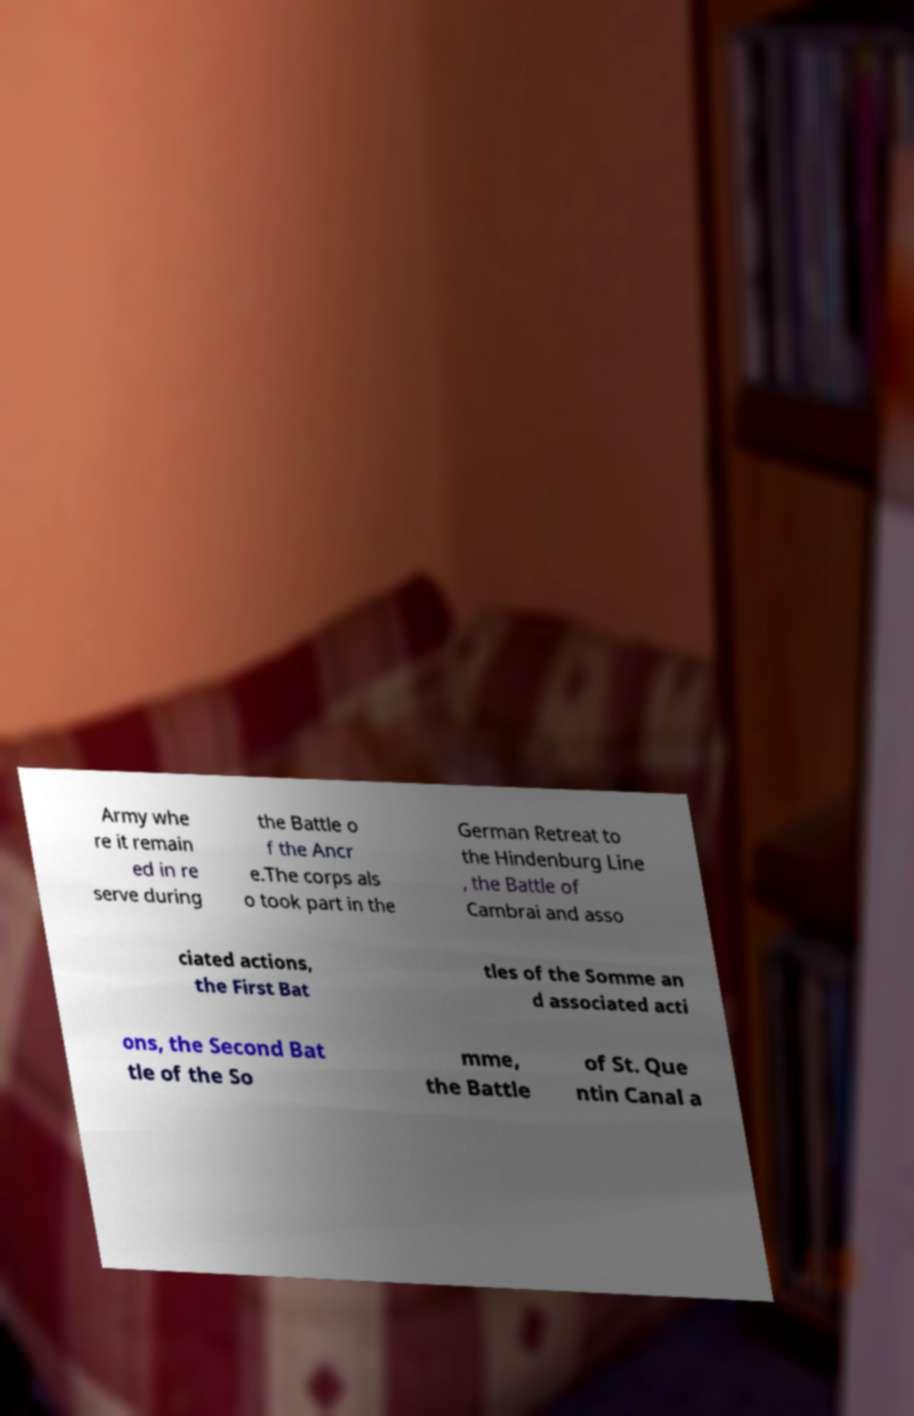Could you extract and type out the text from this image? Army whe re it remain ed in re serve during the Battle o f the Ancr e.The corps als o took part in the German Retreat to the Hindenburg Line , the Battle of Cambrai and asso ciated actions, the First Bat tles of the Somme an d associated acti ons, the Second Bat tle of the So mme, the Battle of St. Que ntin Canal a 